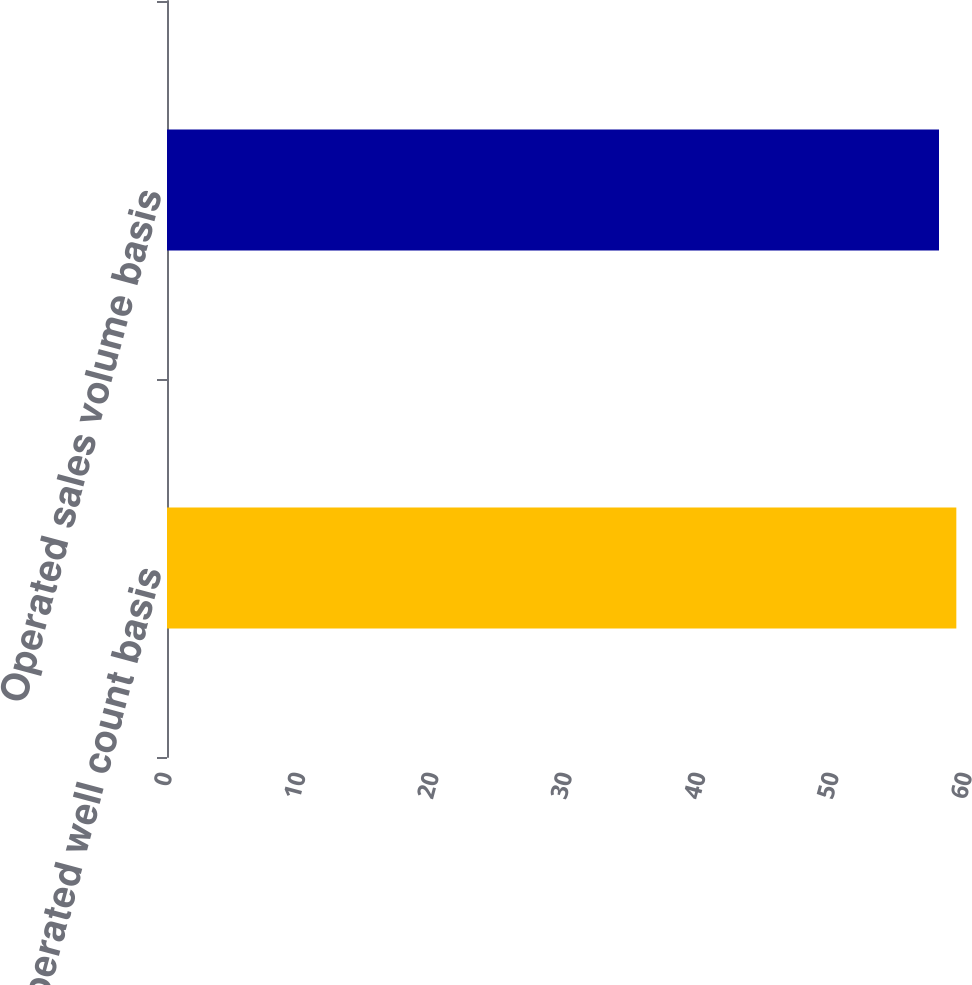Convert chart. <chart><loc_0><loc_0><loc_500><loc_500><bar_chart><fcel>Operated well count basis<fcel>Operated sales volume basis<nl><fcel>59.2<fcel>57.9<nl></chart> 